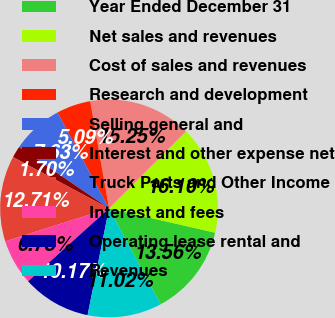Convert chart to OTSL. <chart><loc_0><loc_0><loc_500><loc_500><pie_chart><fcel>Year Ended December 31<fcel>Net sales and revenues<fcel>Cost of sales and revenues<fcel>Research and development<fcel>Selling general and<fcel>Interest and other expense net<fcel>Truck Parts and Other Income<fcel>Interest and fees<fcel>Operating lease rental and<fcel>Revenues<nl><fcel>13.56%<fcel>16.1%<fcel>15.25%<fcel>5.09%<fcel>7.63%<fcel>1.7%<fcel>12.71%<fcel>6.78%<fcel>10.17%<fcel>11.02%<nl></chart> 